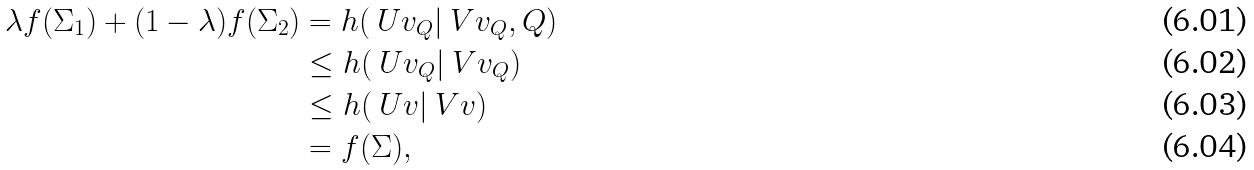Convert formula to latex. <formula><loc_0><loc_0><loc_500><loc_500>\lambda f ( \Sigma _ { 1 } ) + ( 1 - \lambda ) f ( \Sigma _ { 2 } ) & = h ( \ U v _ { Q } | \ V v _ { Q } , Q ) \\ & \leq h ( \ U v _ { Q } | \ V v _ { Q } ) \\ & \leq h ( \ U v | \ V v ) \\ & = f ( \Sigma ) ,</formula> 